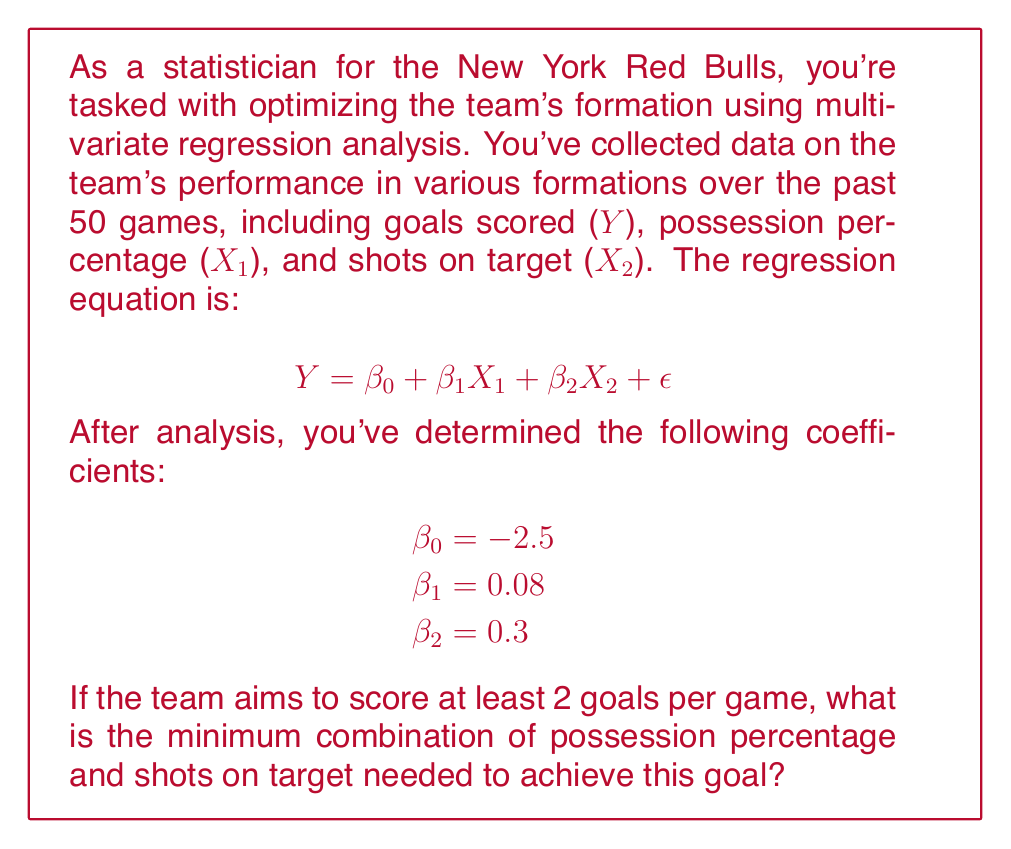Can you solve this math problem? To solve this problem, we'll follow these steps:

1) The regression equation is:
   $$Y = -2.5 + 0.08X_1 + 0.3X_2$$

2) We want Y to be at least 2, so:
   $$2 \leq -2.5 + 0.08X_1 + 0.3X_2$$

3) Rearranging the inequality:
   $$4.5 \leq 0.08X_1 + 0.3X_2$$

4) This inequality represents all combinations of X₁ (possession percentage) and X₂ (shots on target) that would result in 2 or more goals.

5) To find the minimum combination, we need to find the point on this line closest to the origin. This occurs when the line is tangent to an indifference curve.

6) The slope of the line is $-\frac{0.08}{0.3} = -\frac{4}{15}$

7) The equation of the tangent line with the same slope passing through the origin is:
   $$X_2 = -\frac{4}{15}X_1$$

8) Solving the system of equations:
   $$4.5 = 0.08X_1 + 0.3X_2$$
   $$X_2 = -\frac{4}{15}X_1$$

9) Substituting the second equation into the first:
   $$4.5 = 0.08X_1 + 0.3(-\frac{4}{15}X_1) = 0.08X_1 - 0.08X_1 = 0$$

10) This is always true, meaning the lines are parallel. We need to shift the second line until it intersects with the first:
    $$X_2 = -\frac{4}{15}X_1 + b$$

11) Substituting this into the original inequality:
    $$4.5 \leq 0.08X_1 + 0.3(-\frac{4}{15}X_1 + b)$$
    $$4.5 \leq 0.08X_1 - 0.08X_1 + 0.3b$$
    $$4.5 \leq 0.3b$$
    $$b \geq 15$$

12) The minimum occurs when $b = 15$. Substituting back:
    $$X_2 = -\frac{4}{15}X_1 + 15$$

13) Solving this simultaneously with the original inequality:
    $$4.5 = 0.08X_1 + 0.3(-\frac{4}{15}X_1 + 15)$$
    $$4.5 = 0.08X_1 - 0.08X_1 + 4.5$$
    $$X_1 = 56.25$$

14) Substituting this back into the equation from step 12:
    $$X_2 = -\frac{4}{15} * 56.25 + 15 = 15$$

Therefore, the minimum combination is approximately 56.25% possession and 15 shots on target.
Answer: 56.25% possession, 15 shots on target 